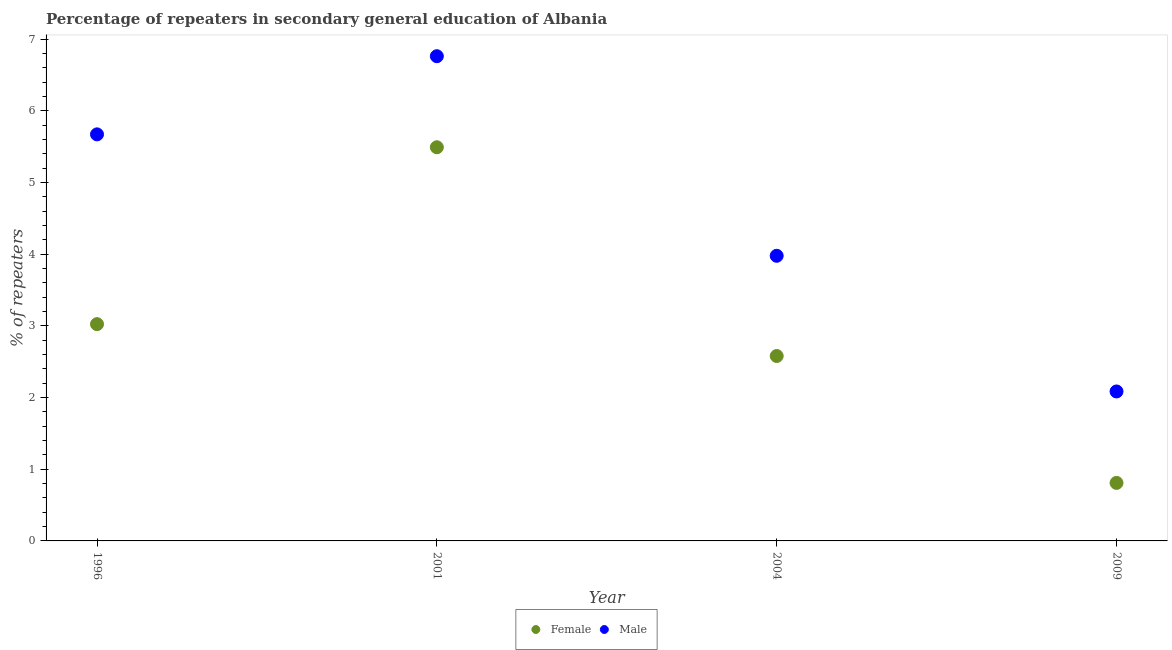Is the number of dotlines equal to the number of legend labels?
Provide a short and direct response. Yes. What is the percentage of male repeaters in 2001?
Make the answer very short. 6.76. Across all years, what is the maximum percentage of female repeaters?
Offer a very short reply. 5.49. Across all years, what is the minimum percentage of male repeaters?
Ensure brevity in your answer.  2.08. In which year was the percentage of male repeaters minimum?
Make the answer very short. 2009. What is the total percentage of female repeaters in the graph?
Keep it short and to the point. 11.9. What is the difference between the percentage of female repeaters in 1996 and that in 2009?
Offer a very short reply. 2.21. What is the difference between the percentage of female repeaters in 2004 and the percentage of male repeaters in 2009?
Give a very brief answer. 0.49. What is the average percentage of male repeaters per year?
Your answer should be very brief. 4.62. In the year 2009, what is the difference between the percentage of male repeaters and percentage of female repeaters?
Keep it short and to the point. 1.28. What is the ratio of the percentage of male repeaters in 1996 to that in 2004?
Your answer should be compact. 1.43. Is the difference between the percentage of female repeaters in 1996 and 2004 greater than the difference between the percentage of male repeaters in 1996 and 2004?
Offer a terse response. No. What is the difference between the highest and the second highest percentage of female repeaters?
Ensure brevity in your answer.  2.47. What is the difference between the highest and the lowest percentage of male repeaters?
Keep it short and to the point. 4.68. In how many years, is the percentage of female repeaters greater than the average percentage of female repeaters taken over all years?
Give a very brief answer. 2. Does the percentage of male repeaters monotonically increase over the years?
Provide a short and direct response. No. Is the percentage of female repeaters strictly less than the percentage of male repeaters over the years?
Keep it short and to the point. Yes. How many dotlines are there?
Give a very brief answer. 2. What is the difference between two consecutive major ticks on the Y-axis?
Offer a terse response. 1. Does the graph contain any zero values?
Make the answer very short. No. Does the graph contain grids?
Your response must be concise. No. Where does the legend appear in the graph?
Your response must be concise. Bottom center. What is the title of the graph?
Ensure brevity in your answer.  Percentage of repeaters in secondary general education of Albania. Does "GDP per capita" appear as one of the legend labels in the graph?
Your answer should be very brief. No. What is the label or title of the X-axis?
Make the answer very short. Year. What is the label or title of the Y-axis?
Your answer should be compact. % of repeaters. What is the % of repeaters of Female in 1996?
Make the answer very short. 3.02. What is the % of repeaters in Male in 1996?
Offer a terse response. 5.67. What is the % of repeaters in Female in 2001?
Provide a succinct answer. 5.49. What is the % of repeaters in Male in 2001?
Offer a very short reply. 6.76. What is the % of repeaters of Female in 2004?
Your answer should be very brief. 2.58. What is the % of repeaters in Male in 2004?
Keep it short and to the point. 3.98. What is the % of repeaters of Female in 2009?
Keep it short and to the point. 0.81. What is the % of repeaters in Male in 2009?
Provide a short and direct response. 2.08. Across all years, what is the maximum % of repeaters in Female?
Provide a short and direct response. 5.49. Across all years, what is the maximum % of repeaters in Male?
Your response must be concise. 6.76. Across all years, what is the minimum % of repeaters in Female?
Ensure brevity in your answer.  0.81. Across all years, what is the minimum % of repeaters of Male?
Your response must be concise. 2.08. What is the total % of repeaters in Female in the graph?
Keep it short and to the point. 11.9. What is the total % of repeaters of Male in the graph?
Give a very brief answer. 18.49. What is the difference between the % of repeaters in Female in 1996 and that in 2001?
Give a very brief answer. -2.47. What is the difference between the % of repeaters of Male in 1996 and that in 2001?
Make the answer very short. -1.09. What is the difference between the % of repeaters in Female in 1996 and that in 2004?
Offer a very short reply. 0.44. What is the difference between the % of repeaters of Male in 1996 and that in 2004?
Provide a short and direct response. 1.69. What is the difference between the % of repeaters of Female in 1996 and that in 2009?
Give a very brief answer. 2.21. What is the difference between the % of repeaters in Male in 1996 and that in 2009?
Provide a short and direct response. 3.59. What is the difference between the % of repeaters of Female in 2001 and that in 2004?
Your answer should be compact. 2.91. What is the difference between the % of repeaters in Male in 2001 and that in 2004?
Ensure brevity in your answer.  2.78. What is the difference between the % of repeaters in Female in 2001 and that in 2009?
Offer a terse response. 4.68. What is the difference between the % of repeaters of Male in 2001 and that in 2009?
Ensure brevity in your answer.  4.68. What is the difference between the % of repeaters in Female in 2004 and that in 2009?
Provide a succinct answer. 1.77. What is the difference between the % of repeaters in Male in 2004 and that in 2009?
Offer a terse response. 1.89. What is the difference between the % of repeaters in Female in 1996 and the % of repeaters in Male in 2001?
Give a very brief answer. -3.74. What is the difference between the % of repeaters in Female in 1996 and the % of repeaters in Male in 2004?
Give a very brief answer. -0.95. What is the difference between the % of repeaters in Female in 1996 and the % of repeaters in Male in 2009?
Ensure brevity in your answer.  0.94. What is the difference between the % of repeaters of Female in 2001 and the % of repeaters of Male in 2004?
Ensure brevity in your answer.  1.51. What is the difference between the % of repeaters of Female in 2001 and the % of repeaters of Male in 2009?
Offer a very short reply. 3.41. What is the difference between the % of repeaters of Female in 2004 and the % of repeaters of Male in 2009?
Your answer should be very brief. 0.49. What is the average % of repeaters of Female per year?
Keep it short and to the point. 2.98. What is the average % of repeaters in Male per year?
Ensure brevity in your answer.  4.62. In the year 1996, what is the difference between the % of repeaters in Female and % of repeaters in Male?
Your answer should be compact. -2.65. In the year 2001, what is the difference between the % of repeaters of Female and % of repeaters of Male?
Offer a terse response. -1.27. In the year 2004, what is the difference between the % of repeaters of Female and % of repeaters of Male?
Offer a terse response. -1.4. In the year 2009, what is the difference between the % of repeaters of Female and % of repeaters of Male?
Your answer should be very brief. -1.28. What is the ratio of the % of repeaters in Female in 1996 to that in 2001?
Offer a terse response. 0.55. What is the ratio of the % of repeaters in Male in 1996 to that in 2001?
Your answer should be compact. 0.84. What is the ratio of the % of repeaters of Female in 1996 to that in 2004?
Make the answer very short. 1.17. What is the ratio of the % of repeaters in Male in 1996 to that in 2004?
Offer a very short reply. 1.43. What is the ratio of the % of repeaters of Female in 1996 to that in 2009?
Provide a short and direct response. 3.74. What is the ratio of the % of repeaters of Male in 1996 to that in 2009?
Keep it short and to the point. 2.72. What is the ratio of the % of repeaters in Female in 2001 to that in 2004?
Keep it short and to the point. 2.13. What is the ratio of the % of repeaters in Female in 2001 to that in 2009?
Offer a terse response. 6.79. What is the ratio of the % of repeaters in Male in 2001 to that in 2009?
Offer a very short reply. 3.24. What is the ratio of the % of repeaters of Female in 2004 to that in 2009?
Make the answer very short. 3.19. What is the ratio of the % of repeaters in Male in 2004 to that in 2009?
Give a very brief answer. 1.91. What is the difference between the highest and the second highest % of repeaters in Female?
Keep it short and to the point. 2.47. What is the difference between the highest and the second highest % of repeaters of Male?
Keep it short and to the point. 1.09. What is the difference between the highest and the lowest % of repeaters of Female?
Give a very brief answer. 4.68. What is the difference between the highest and the lowest % of repeaters of Male?
Your response must be concise. 4.68. 